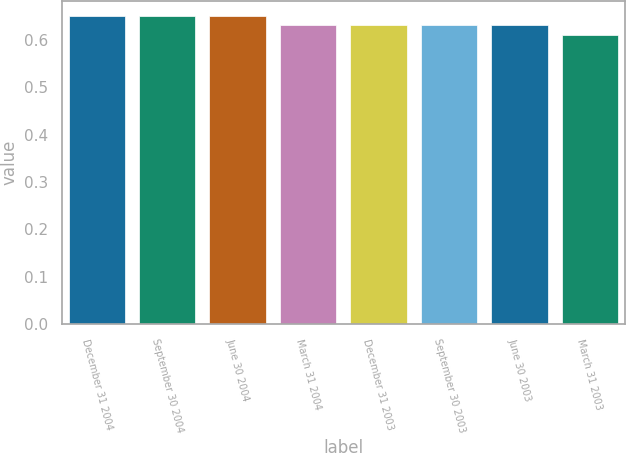Convert chart. <chart><loc_0><loc_0><loc_500><loc_500><bar_chart><fcel>December 31 2004<fcel>September 30 2004<fcel>June 30 2004<fcel>March 31 2004<fcel>December 31 2003<fcel>September 30 2003<fcel>June 30 2003<fcel>March 31 2003<nl><fcel>0.65<fcel>0.65<fcel>0.65<fcel>0.63<fcel>0.63<fcel>0.63<fcel>0.63<fcel>0.61<nl></chart> 